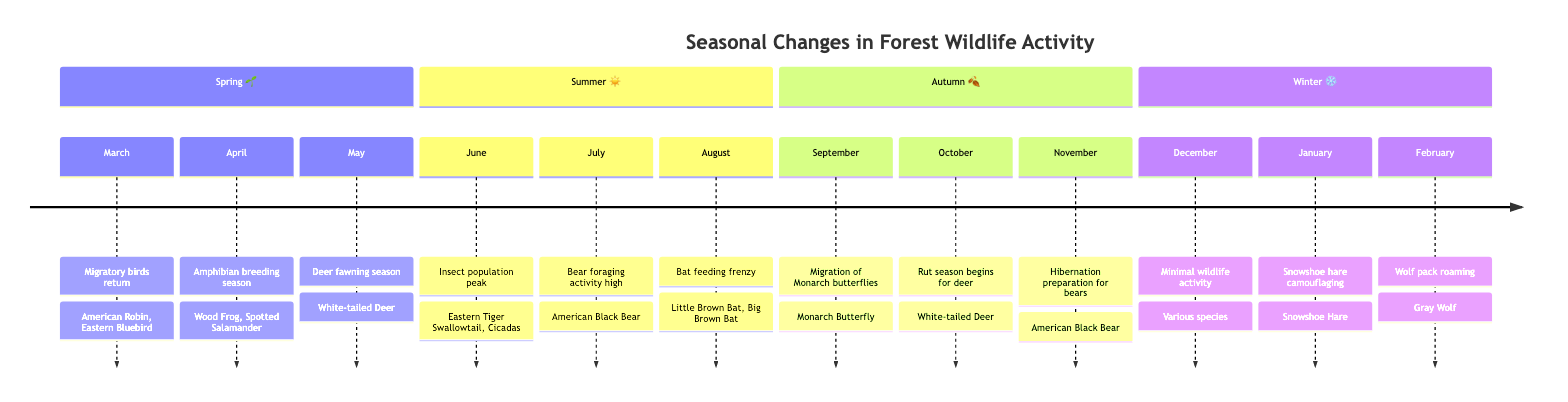What season do migratory birds return? According to the timeline, migratory birds return in March during the Spring season.
Answer: Spring How many species are involved in the amphibian breeding season? In the event listed for April, there are two species mentioned: Wood Frog and Spotted Salamander. Thus, the count is two species.
Answer: 2 What activity peaks in June? The timeline indicates that the insect population peak is the activity specified for June.
Answer: Insect population peak Which deer activity occurs in October? The diagram states that the rut season begins for deer in October, which pertains specifically to White-tailed Deer.
Answer: Rut season begins Which animal prepares for hibernation in November? The timeline shows that American Black Bear prepares for hibernation in November as indicated under the Autumn section.
Answer: American Black Bear What is unique about December's wildlife activity? The timeline notes that December has minimal wildlife activity, indicating a significant decrease in overall wildlife activities during this month.
Answer: Minimal wildlife activity Which species is noted for camouflaging in January? In January, the timeline specifies that Snowshoe Hare is recognized for its camouflaging behavior.
Answer: Snowshoe Hare How do migratory birds and Monarch butterflies relate in terms of season? Migratory birds return in Spring, while Monarch butterflies migrate in Autumn. Both events occur in the respective seasons, thus they are connected by their seasonal timing.
Answer: Different seasons What is the last activity noted in the timeline? According to the timeline provided, the last activity noted is "Wolf pack roaming" occurring in February.
Answer: Wolf pack roaming 